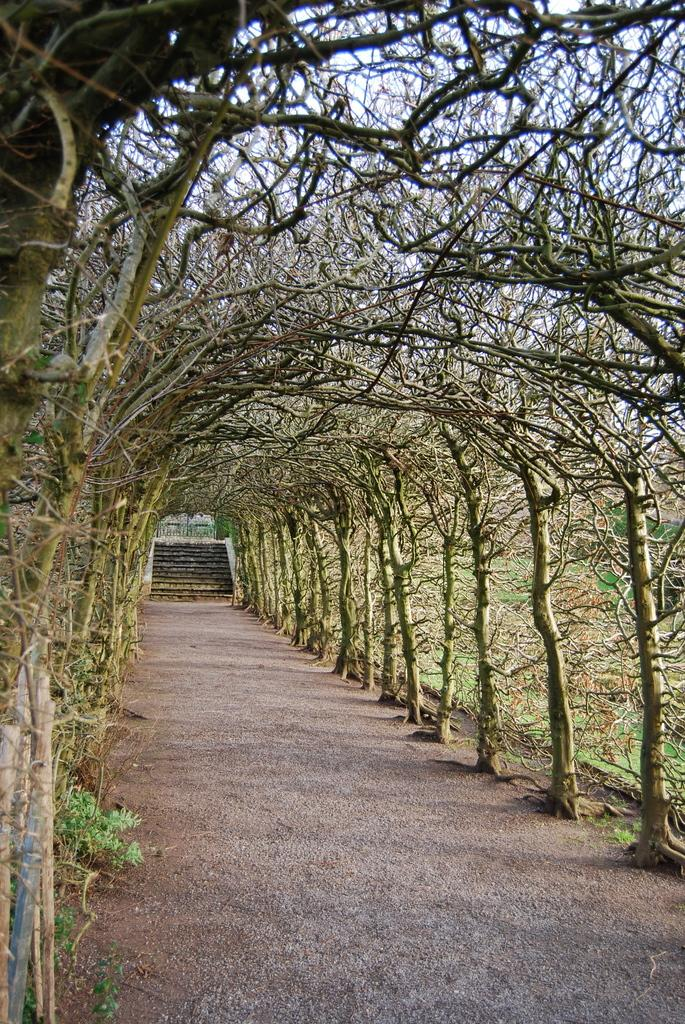What type of vegetation can be seen in the image? There are trees in the image. What architectural feature is present in the image? There are stairs in the image. What is visible at the bottom of the image? Ground is visible at the bottom of the image. Can you describe the flock of birds flying over the trees in the image? There is no mention of birds or a flock in the provided facts, so we cannot describe any birds in the image. 